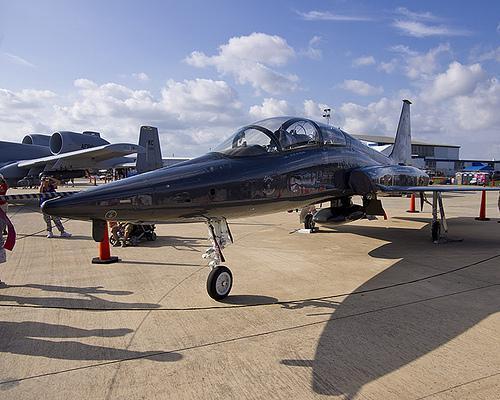How many planes are visible?
Give a very brief answer. 3. 